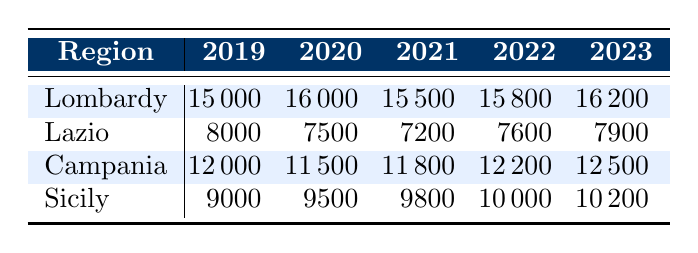What was the total number of drug-related arrests in Lombardy over the last five years? To find the total, we need to sum the arrests from each year in Lombardy: 15000 (2019) + 16000 (2020) + 15500 (2021) + 15800 (2022) + 16200 (2023) = 78500.
Answer: 78500 Which region had the highest number of arrests in 2022? From the table, in 2022, Lombardy had 15800 arrests, Lazio had 7600, Campania had 12200, and Sicily had 10000. Therefore, Lombardy had the highest number of arrests.
Answer: Lombardy Did the number of drug-related arrests in Lazio increase from 2019 to 2023? In 2019, Lazio had 8000 arrests, which decreased to 7500 in 2020, further decreased to 7200 in 2021, then increased to 7600 in 2022, and finally to 7900 in 2023. Overall, it did not increase consistently over the years.
Answer: No What is the average number of arrests in Campania during the five years? To calculate the average, we sum the arrests: 12000 + 11500 + 11800 + 12200 + 12500 = 60000. Dividing by 5 years gives an average of 60000/5 = 12000.
Answer: 12000 In which year did the arrests in Sicily exceed 10000 for the first time? Looking at the arrests in Sicily, the numbers were 9000 (2019), 9500 (2020), 9800 (2021), 10000 (2022), and increased to 10200 in 2023. Sicily exceeded 10000 arrests starting in 2022.
Answer: 2022 Which region had the lowest number of arrests in 2021? In 2021, the table shows Lombardy had 15500, Lazio had 7200, Campania had 11800, and Sicily had 9800. The lowest number of arrests was in Lazio.
Answer: Lazio Is there a trend of increasing arrests in Lombardy over the last five years? In Lombardy, the number of arrests was 15000 in 2019, 16000 in 2020, and has generally risen each year to 16200 in 2023, indicating a clear upward trend.
Answer: Yes What was the difference in the number of arrests between Lazio and Campania in 2023? In 2023, Lazio recorded 7900 arrests while Campania had 12500. The difference is 12500 - 7900 = 4600.
Answer: 4600 